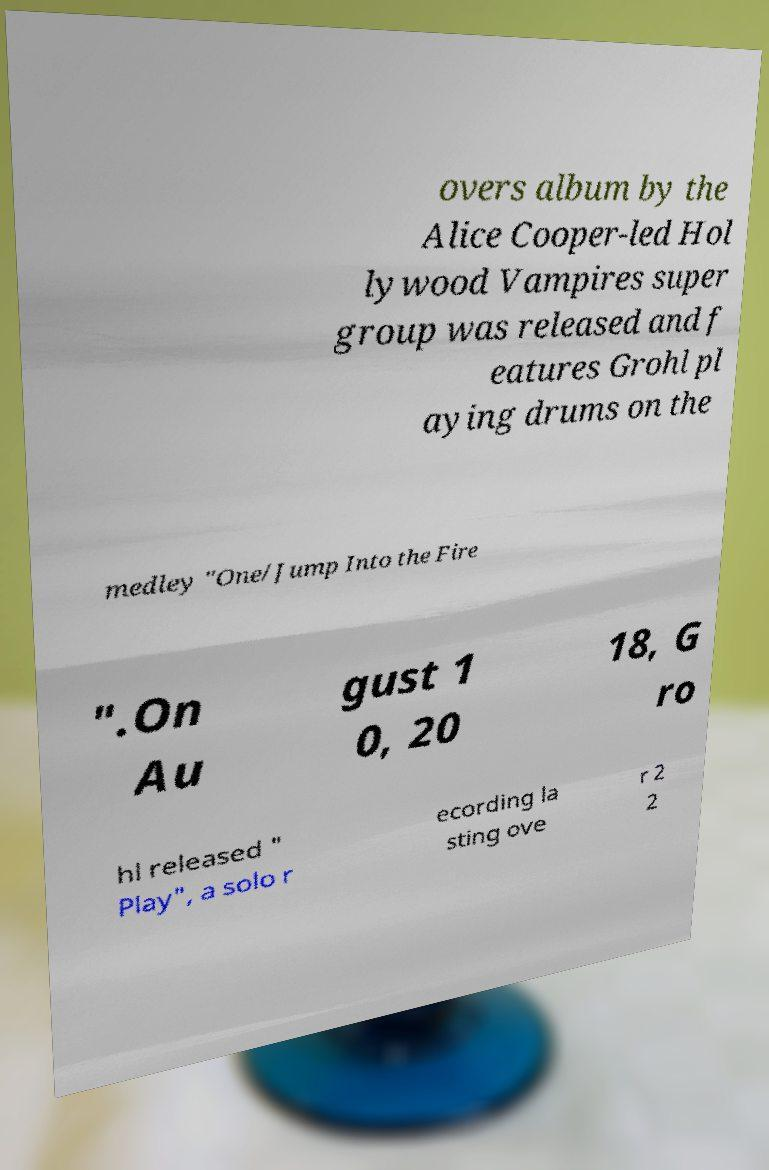Could you extract and type out the text from this image? overs album by the Alice Cooper-led Hol lywood Vampires super group was released and f eatures Grohl pl aying drums on the medley "One/Jump Into the Fire ".On Au gust 1 0, 20 18, G ro hl released " Play", a solo r ecording la sting ove r 2 2 